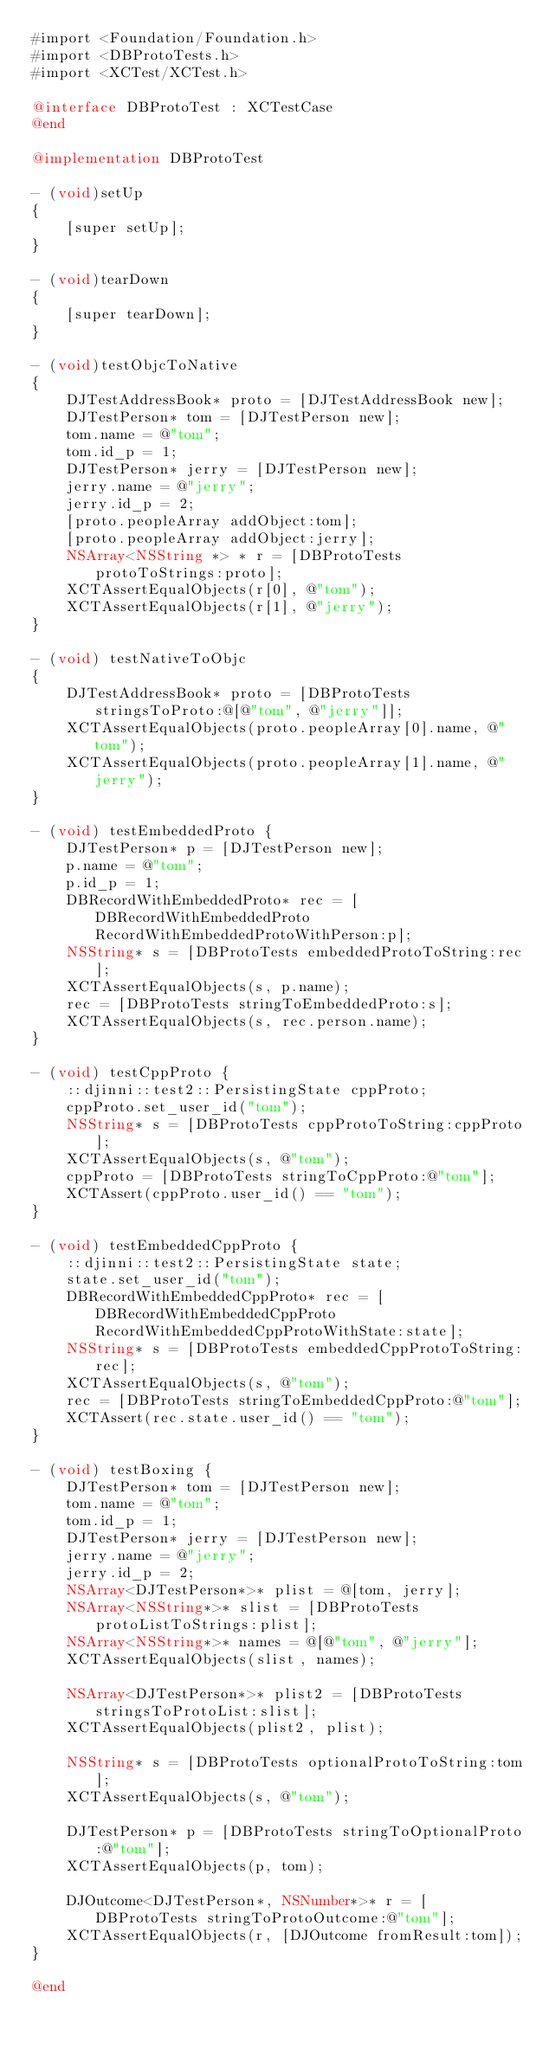<code> <loc_0><loc_0><loc_500><loc_500><_ObjectiveC_>#import <Foundation/Foundation.h>
#import <DBProtoTests.h>
#import <XCTest/XCTest.h>

@interface DBProtoTest : XCTestCase
@end

@implementation DBProtoTest

- (void)setUp
{
    [super setUp];
}

- (void)tearDown
{
    [super tearDown];
}

- (void)testObjcToNative
{
    DJTestAddressBook* proto = [DJTestAddressBook new];
    DJTestPerson* tom = [DJTestPerson new];
    tom.name = @"tom";
    tom.id_p = 1;
    DJTestPerson* jerry = [DJTestPerson new];
    jerry.name = @"jerry";
    jerry.id_p = 2;
    [proto.peopleArray addObject:tom];
    [proto.peopleArray addObject:jerry];
    NSArray<NSString *> * r = [DBProtoTests protoToStrings:proto];
    XCTAssertEqualObjects(r[0], @"tom");
    XCTAssertEqualObjects(r[1], @"jerry");
}

- (void) testNativeToObjc
{
    DJTestAddressBook* proto = [DBProtoTests stringsToProto:@[@"tom", @"jerry"]];
    XCTAssertEqualObjects(proto.peopleArray[0].name, @"tom");
    XCTAssertEqualObjects(proto.peopleArray[1].name, @"jerry");
}

- (void) testEmbeddedProto {
    DJTestPerson* p = [DJTestPerson new];
    p.name = @"tom";
    p.id_p = 1;
    DBRecordWithEmbeddedProto* rec = [DBRecordWithEmbeddedProto RecordWithEmbeddedProtoWithPerson:p];
    NSString* s = [DBProtoTests embeddedProtoToString:rec];
    XCTAssertEqualObjects(s, p.name);
    rec = [DBProtoTests stringToEmbeddedProto:s];
    XCTAssertEqualObjects(s, rec.person.name);
}

- (void) testCppProto {
    ::djinni::test2::PersistingState cppProto;
    cppProto.set_user_id("tom");
    NSString* s = [DBProtoTests cppProtoToString:cppProto];
    XCTAssertEqualObjects(s, @"tom");
    cppProto = [DBProtoTests stringToCppProto:@"tom"];
    XCTAssert(cppProto.user_id() == "tom");
}

- (void) testEmbeddedCppProto {
    ::djinni::test2::PersistingState state;
    state.set_user_id("tom");
    DBRecordWithEmbeddedCppProto* rec = [DBRecordWithEmbeddedCppProto RecordWithEmbeddedCppProtoWithState:state];
    NSString* s = [DBProtoTests embeddedCppProtoToString:rec];
    XCTAssertEqualObjects(s, @"tom");
    rec = [DBProtoTests stringToEmbeddedCppProto:@"tom"];
    XCTAssert(rec.state.user_id() == "tom");    
}

- (void) testBoxing {
    DJTestPerson* tom = [DJTestPerson new];
    tom.name = @"tom";
    tom.id_p = 1;
    DJTestPerson* jerry = [DJTestPerson new];
    jerry.name = @"jerry";
    jerry.id_p = 2;
    NSArray<DJTestPerson*>* plist = @[tom, jerry];
    NSArray<NSString*>* slist = [DBProtoTests protoListToStrings:plist];
    NSArray<NSString*>* names = @[@"tom", @"jerry"];
    XCTAssertEqualObjects(slist, names);

    NSArray<DJTestPerson*>* plist2 = [DBProtoTests stringsToProtoList:slist];
    XCTAssertEqualObjects(plist2, plist);

    NSString* s = [DBProtoTests optionalProtoToString:tom];
    XCTAssertEqualObjects(s, @"tom");

    DJTestPerson* p = [DBProtoTests stringToOptionalProto:@"tom"];
    XCTAssertEqualObjects(p, tom);

    DJOutcome<DJTestPerson*, NSNumber*>* r = [DBProtoTests stringToProtoOutcome:@"tom"];
    XCTAssertEqualObjects(r, [DJOutcome fromResult:tom]);
}

@end
</code> 